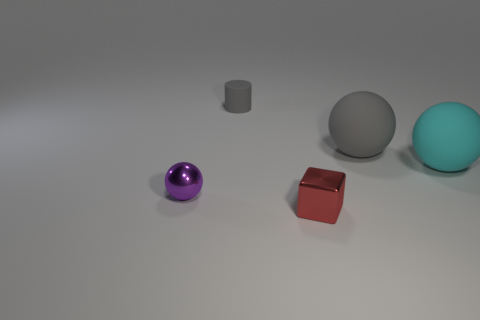There is a shiny thing that is in front of the purple metallic ball; is it the same color as the rubber object that is behind the gray rubber ball?
Offer a very short reply. No. What number of small metal spheres are on the right side of the tiny red thing?
Your answer should be compact. 0. Is there a tiny object in front of the small object in front of the metallic thing left of the gray matte cylinder?
Your response must be concise. No. What number of purple matte balls are the same size as the cyan rubber object?
Make the answer very short. 0. What material is the small sphere that is on the left side of the metal thing that is right of the tiny gray matte object?
Provide a short and direct response. Metal. What is the shape of the tiny metal object behind the tiny block that is in front of the ball that is to the left of the red metal cube?
Offer a very short reply. Sphere. Do the big object that is to the left of the cyan sphere and the metallic object in front of the purple sphere have the same shape?
Give a very brief answer. No. How many other objects are there of the same material as the tiny block?
Your answer should be very brief. 1. The cyan object that is made of the same material as the tiny gray object is what shape?
Your answer should be compact. Sphere. Do the red shiny block and the purple object have the same size?
Offer a very short reply. Yes. 